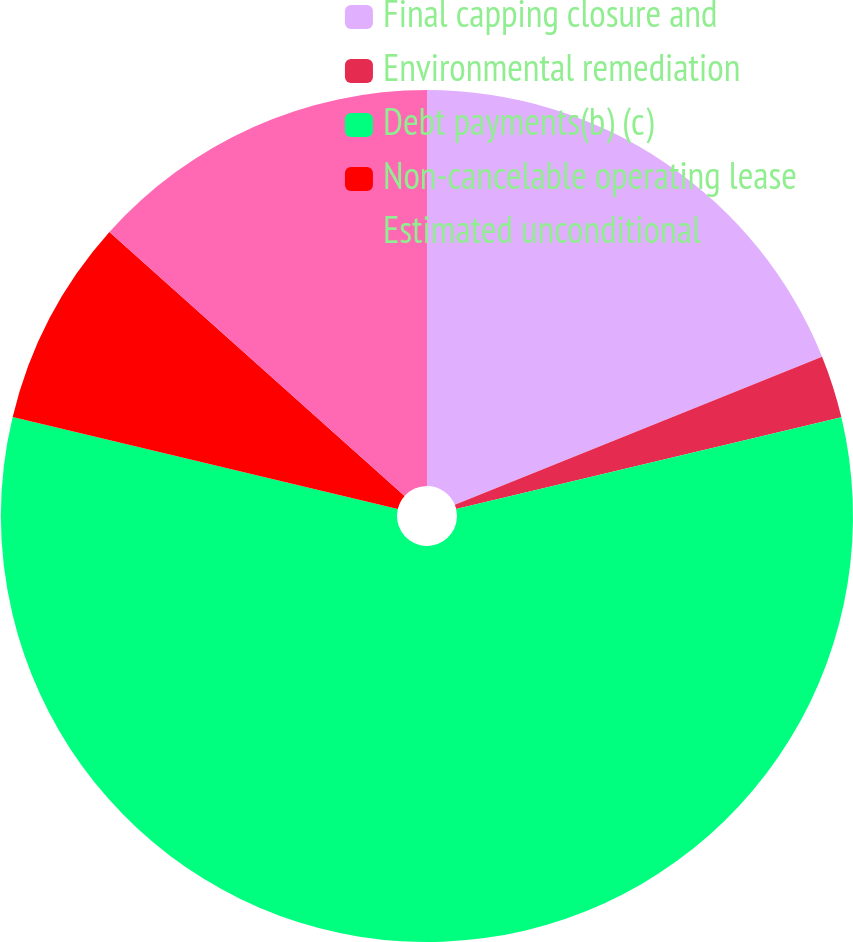Convert chart to OTSL. <chart><loc_0><loc_0><loc_500><loc_500><pie_chart><fcel>Final capping closure and<fcel>Environmental remediation<fcel>Debt payments(b) (c)<fcel>Non-cancelable operating lease<fcel>Estimated unconditional<nl><fcel>18.9%<fcel>2.38%<fcel>57.45%<fcel>7.88%<fcel>13.39%<nl></chart> 